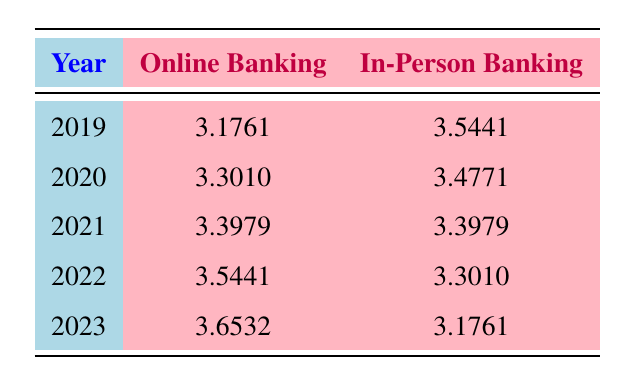What is the log value for online banking in 2021? The table shows the log value for online banking in 2021 as 3.3979.
Answer: 3.3979 What was the highest log value for in-person banking? By looking through the in-person banking log values, the highest is 3.5441 in 2019.
Answer: 3.5441 What is the difference between the log values for online banking in 2023 and 2022? The log value for online banking in 2023 is 3.6532 and in 2022 is 3.5441. The difference is 3.6532 - 3.5441 = 0.1091.
Answer: 0.1091 Was the log value for online banking ever lower than the log value for in-person banking? Yes, in 2019 and 2020, the log values for in-person banking were higher than the log values for online banking (3.5441 vs 3.1761 and 3.4771 vs 3.3010, respectively).
Answer: Yes What was the average log value for online banking from 2019 to 2023? To find the average, sum the log values for online banking: 3.1761 + 3.3010 + 3.3979 + 3.5441 + 3.6532 = 16.0723. Then divide by 5: 16.0723 / 5 = 3.21446.
Answer: 3.2145 In which year did online banking surpass in-person banking in log value for the first time? The first year where the log value for online banking surpassed in-person banking is 2022, with values of 3.5441 (online) and 3.3010 (in-person).
Answer: 2022 What trend can be observed for online banking from 2019 to 2023? The log values for online banking consistently increased each year, starting from 3.1761 in 2019 to 3.6532 in 2023.
Answer: Increasing Is it true that in-person banking had a higher log value than online banking in 2020? Yes, in 2020, the log value for in-person banking was 3.4771, while for online banking it was 3.3010, indicating in-person banking was higher.
Answer: Yes 